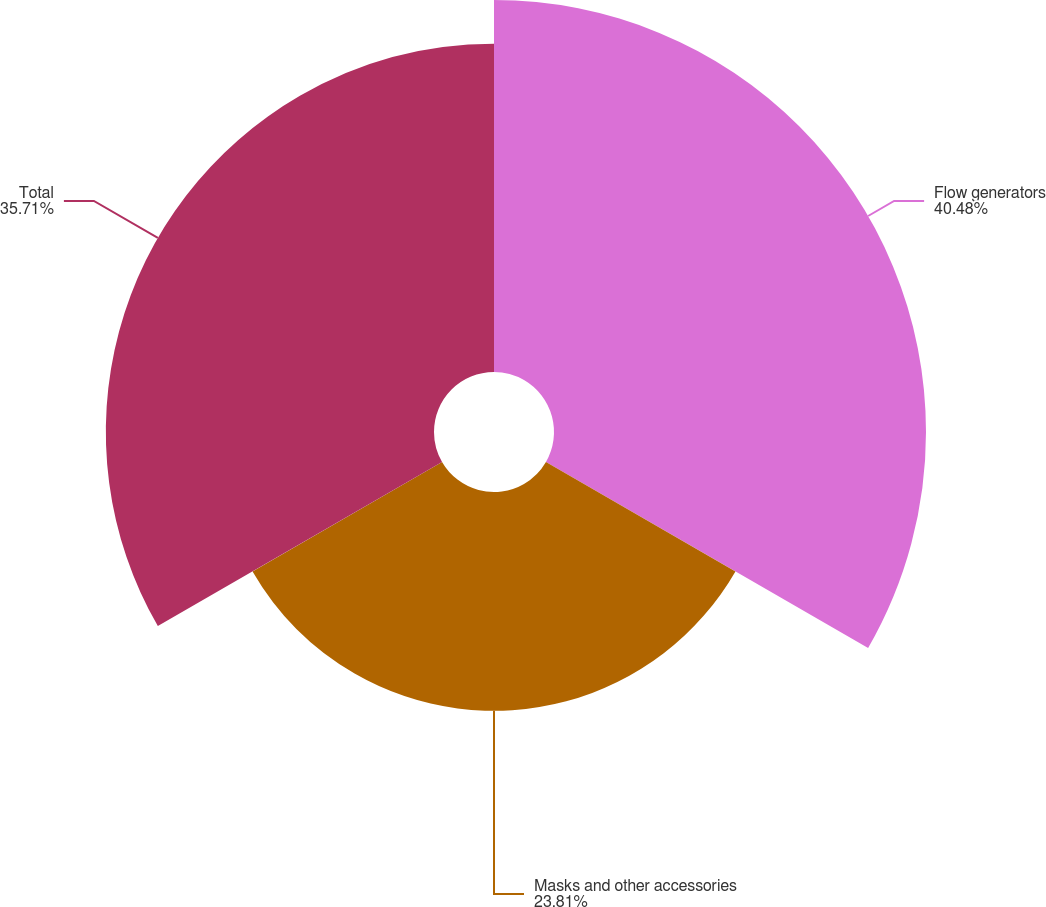Convert chart. <chart><loc_0><loc_0><loc_500><loc_500><pie_chart><fcel>Flow generators<fcel>Masks and other accessories<fcel>Total<nl><fcel>40.48%<fcel>23.81%<fcel>35.71%<nl></chart> 